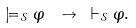Convert formula to latex. <formula><loc_0><loc_0><loc_500><loc_500>\models _ { \mathcal { S } } \varphi \ \to \ \vdash _ { \mathcal { S } } \varphi .</formula> 